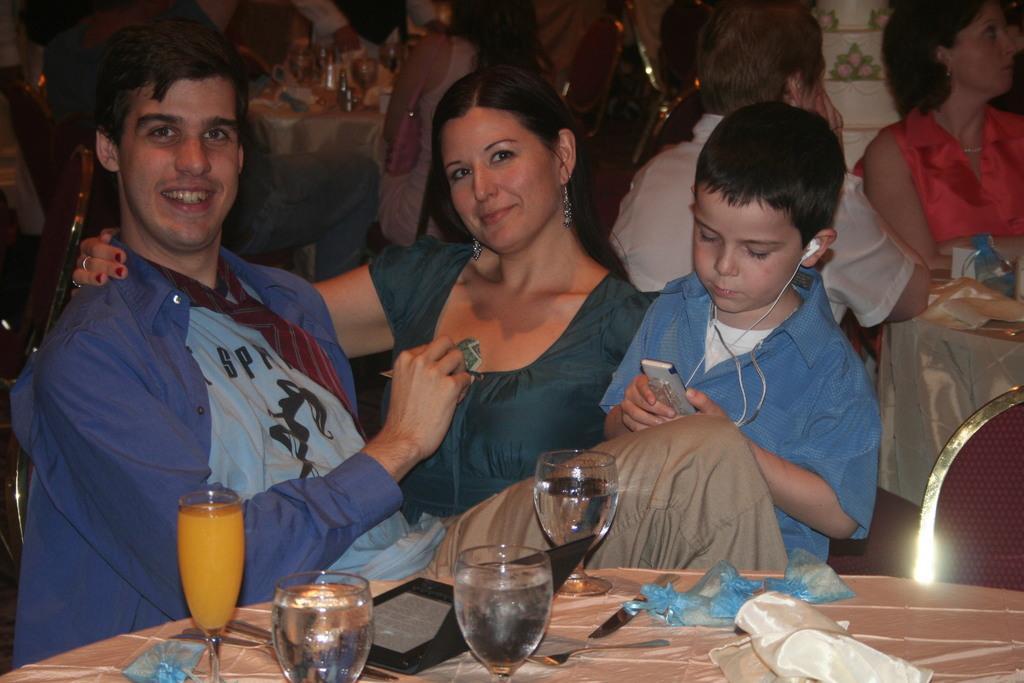Can you describe this image briefly? In this image I see a man, a woman and a child over here, I see that these both are sitting on chairs and both of them are smiling. I see that this child is holding a device in is hand and there are ear phones in his ears , I can also see a table in front of them on which there are glasses and other things and I see another chair over here. In the background I see few people, tables and chairs. 